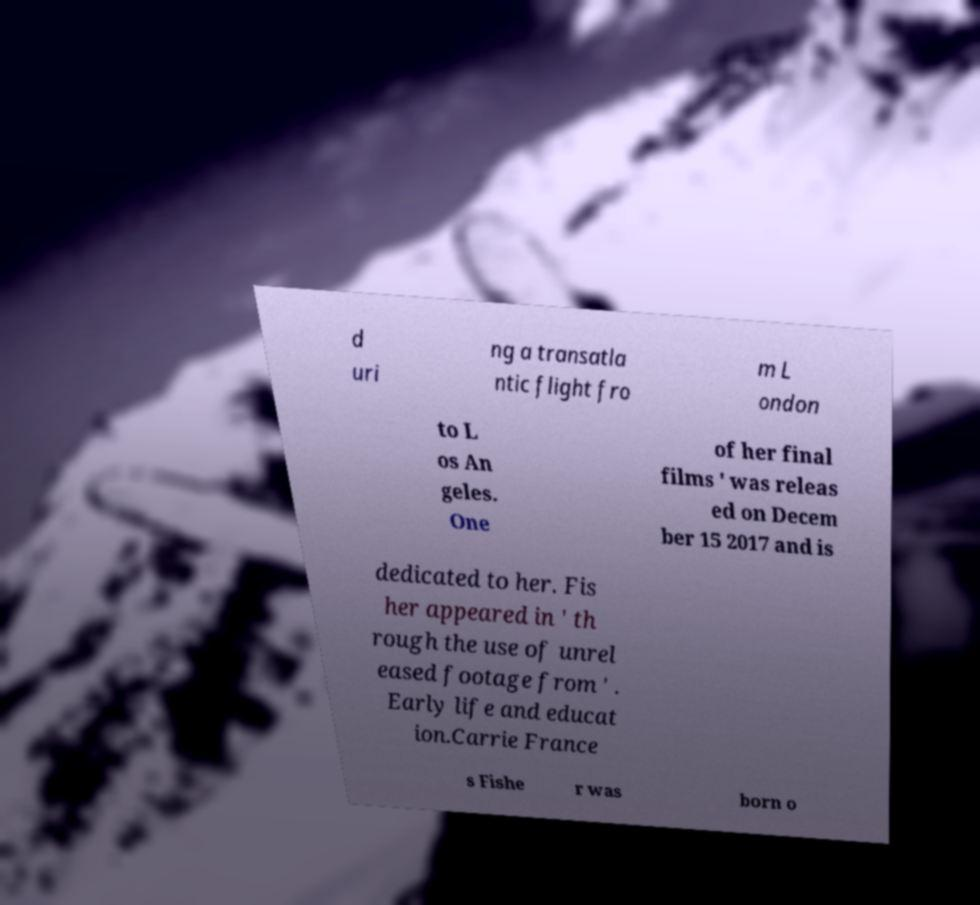Please read and relay the text visible in this image. What does it say? d uri ng a transatla ntic flight fro m L ondon to L os An geles. One of her final films ' was releas ed on Decem ber 15 2017 and is dedicated to her. Fis her appeared in ' th rough the use of unrel eased footage from ' . Early life and educat ion.Carrie France s Fishe r was born o 